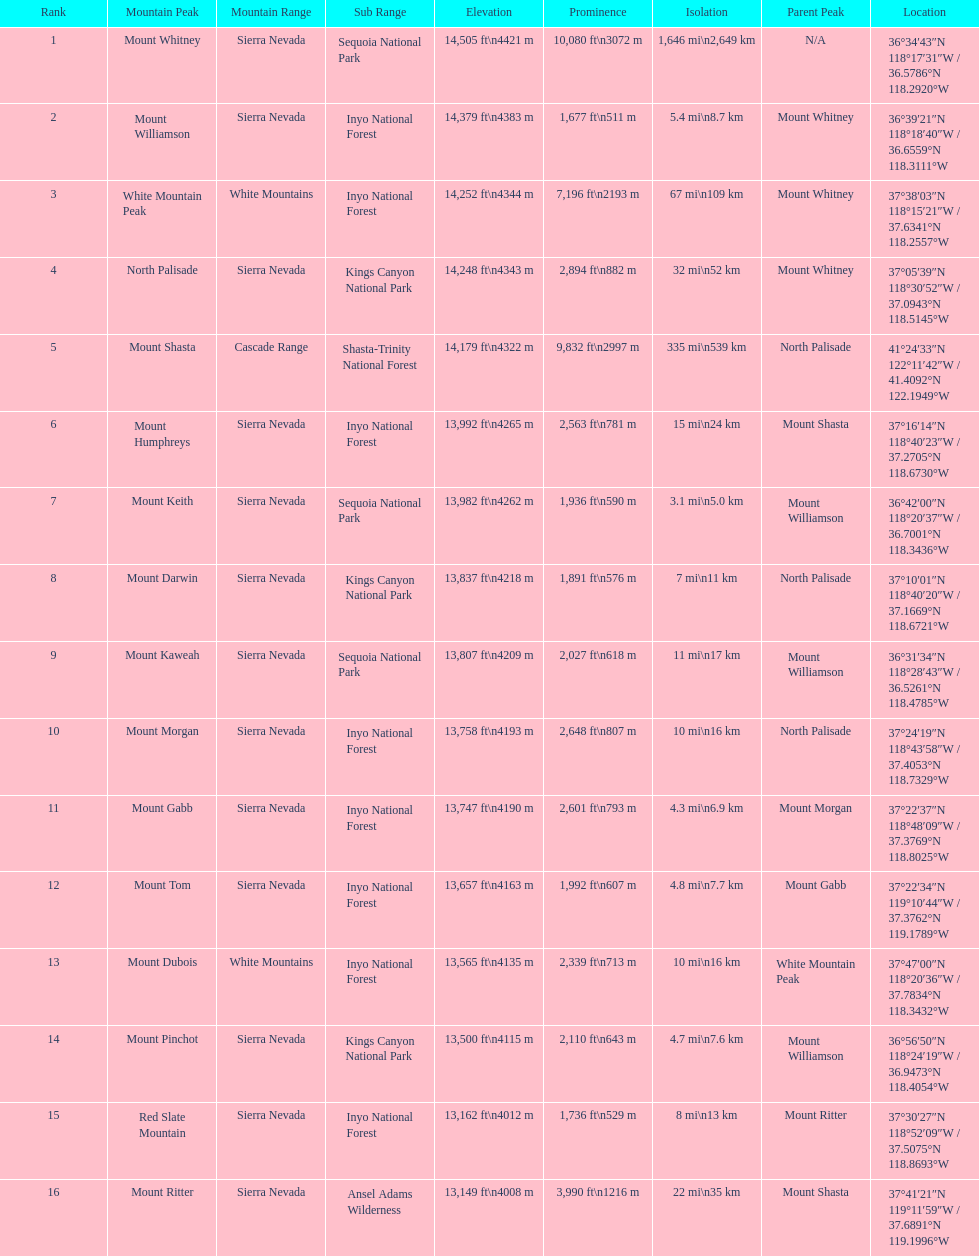In feet, what is the difference between the tallest peak and the 9th tallest peak in california? 698 ft. 